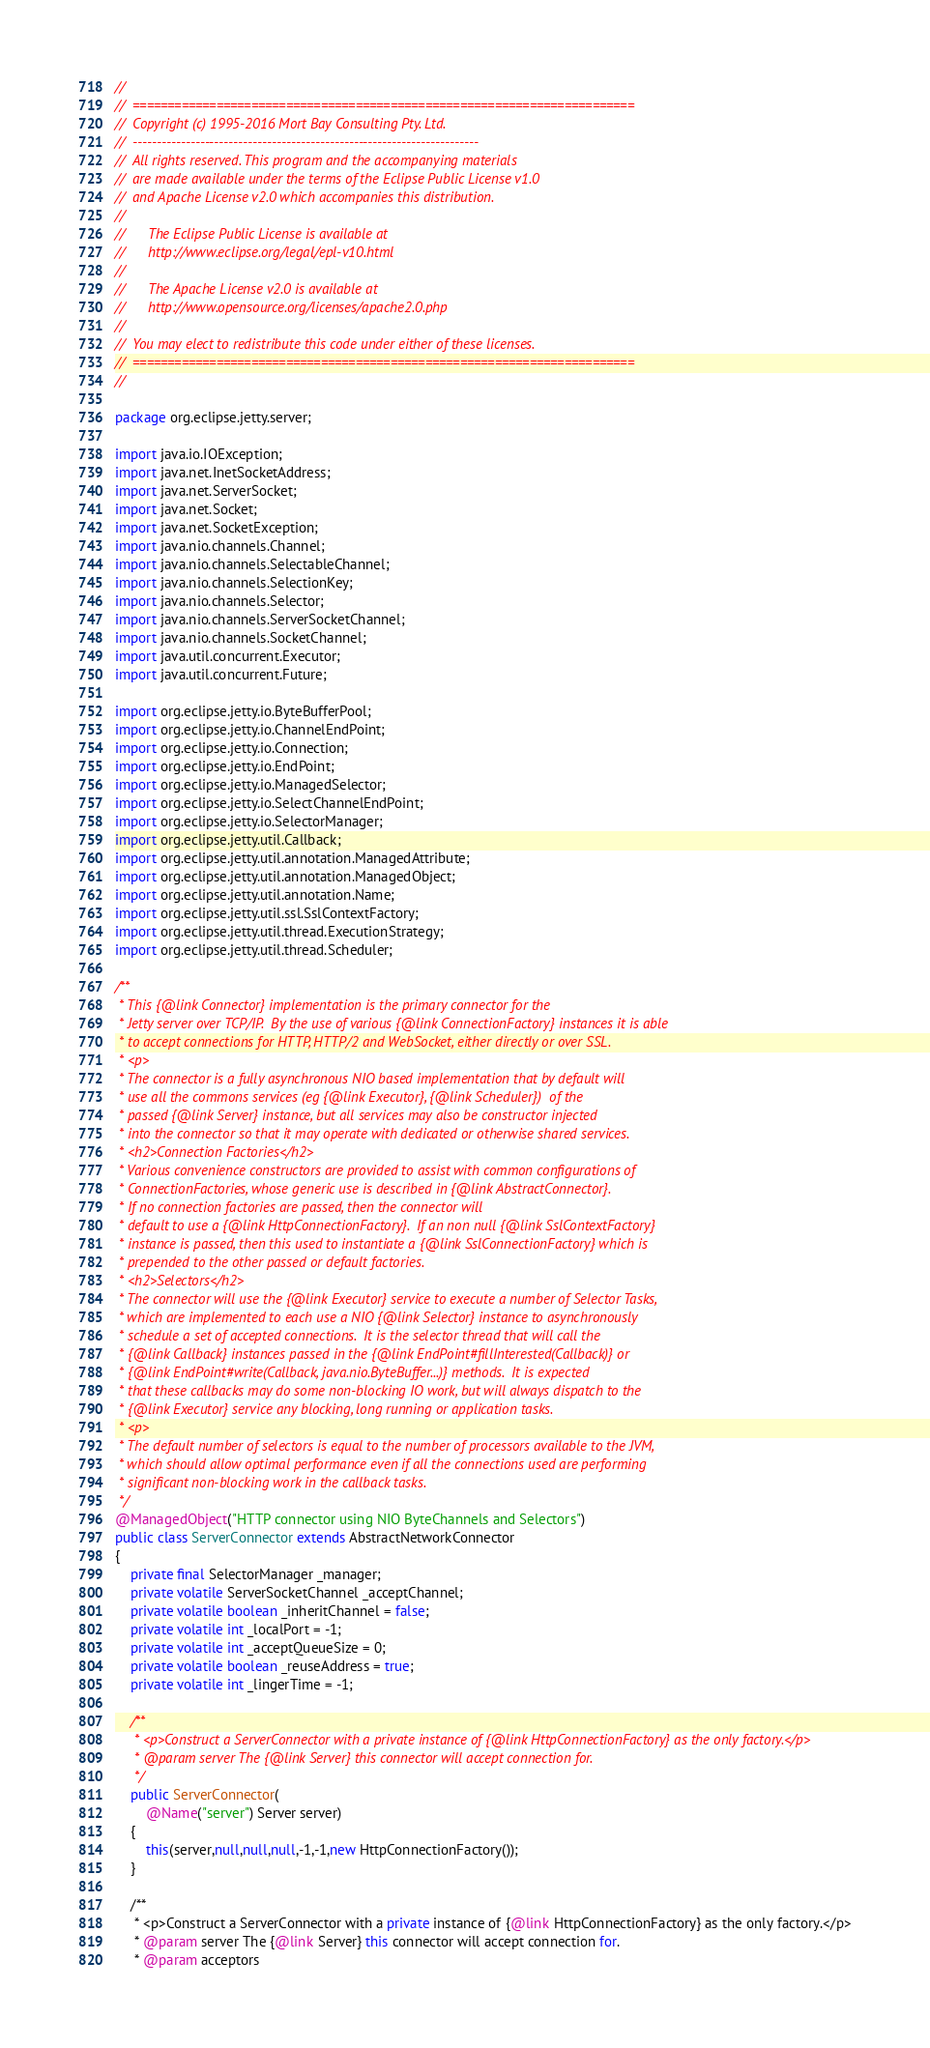<code> <loc_0><loc_0><loc_500><loc_500><_Java_>//
//  ========================================================================
//  Copyright (c) 1995-2016 Mort Bay Consulting Pty. Ltd.
//  ------------------------------------------------------------------------
//  All rights reserved. This program and the accompanying materials
//  are made available under the terms of the Eclipse Public License v1.0
//  and Apache License v2.0 which accompanies this distribution.
//
//      The Eclipse Public License is available at
//      http://www.eclipse.org/legal/epl-v10.html
//
//      The Apache License v2.0 is available at
//      http://www.opensource.org/licenses/apache2.0.php
//
//  You may elect to redistribute this code under either of these licenses.
//  ========================================================================
//

package org.eclipse.jetty.server;

import java.io.IOException;
import java.net.InetSocketAddress;
import java.net.ServerSocket;
import java.net.Socket;
import java.net.SocketException;
import java.nio.channels.Channel;
import java.nio.channels.SelectableChannel;
import java.nio.channels.SelectionKey;
import java.nio.channels.Selector;
import java.nio.channels.ServerSocketChannel;
import java.nio.channels.SocketChannel;
import java.util.concurrent.Executor;
import java.util.concurrent.Future;

import org.eclipse.jetty.io.ByteBufferPool;
import org.eclipse.jetty.io.ChannelEndPoint;
import org.eclipse.jetty.io.Connection;
import org.eclipse.jetty.io.EndPoint;
import org.eclipse.jetty.io.ManagedSelector;
import org.eclipse.jetty.io.SelectChannelEndPoint;
import org.eclipse.jetty.io.SelectorManager;
import org.eclipse.jetty.util.Callback;
import org.eclipse.jetty.util.annotation.ManagedAttribute;
import org.eclipse.jetty.util.annotation.ManagedObject;
import org.eclipse.jetty.util.annotation.Name;
import org.eclipse.jetty.util.ssl.SslContextFactory;
import org.eclipse.jetty.util.thread.ExecutionStrategy;
import org.eclipse.jetty.util.thread.Scheduler;

/**
 * This {@link Connector} implementation is the primary connector for the
 * Jetty server over TCP/IP.  By the use of various {@link ConnectionFactory} instances it is able
 * to accept connections for HTTP, HTTP/2 and WebSocket, either directly or over SSL.
 * <p>
 * The connector is a fully asynchronous NIO based implementation that by default will
 * use all the commons services (eg {@link Executor}, {@link Scheduler})  of the
 * passed {@link Server} instance, but all services may also be constructor injected
 * into the connector so that it may operate with dedicated or otherwise shared services.
 * <h2>Connection Factories</h2>
 * Various convenience constructors are provided to assist with common configurations of
 * ConnectionFactories, whose generic use is described in {@link AbstractConnector}.
 * If no connection factories are passed, then the connector will
 * default to use a {@link HttpConnectionFactory}.  If an non null {@link SslContextFactory}
 * instance is passed, then this used to instantiate a {@link SslConnectionFactory} which is
 * prepended to the other passed or default factories.
 * <h2>Selectors</h2>
 * The connector will use the {@link Executor} service to execute a number of Selector Tasks,
 * which are implemented to each use a NIO {@link Selector} instance to asynchronously
 * schedule a set of accepted connections.  It is the selector thread that will call the
 * {@link Callback} instances passed in the {@link EndPoint#fillInterested(Callback)} or
 * {@link EndPoint#write(Callback, java.nio.ByteBuffer...)} methods.  It is expected
 * that these callbacks may do some non-blocking IO work, but will always dispatch to the
 * {@link Executor} service any blocking, long running or application tasks.
 * <p>
 * The default number of selectors is equal to the number of processors available to the JVM,
 * which should allow optimal performance even if all the connections used are performing
 * significant non-blocking work in the callback tasks.
 */
@ManagedObject("HTTP connector using NIO ByteChannels and Selectors")
public class ServerConnector extends AbstractNetworkConnector
{
    private final SelectorManager _manager;
    private volatile ServerSocketChannel _acceptChannel;
    private volatile boolean _inheritChannel = false;
    private volatile int _localPort = -1;
    private volatile int _acceptQueueSize = 0;
    private volatile boolean _reuseAddress = true;
    private volatile int _lingerTime = -1;

    /**
     * <p>Construct a ServerConnector with a private instance of {@link HttpConnectionFactory} as the only factory.</p>
     * @param server The {@link Server} this connector will accept connection for.
     */
    public ServerConnector(
        @Name("server") Server server)
    {
        this(server,null,null,null,-1,-1,new HttpConnectionFactory());
    }

    /**
     * <p>Construct a ServerConnector with a private instance of {@link HttpConnectionFactory} as the only factory.</p>
     * @param server The {@link Server} this connector will accept connection for.
     * @param acceptors</code> 